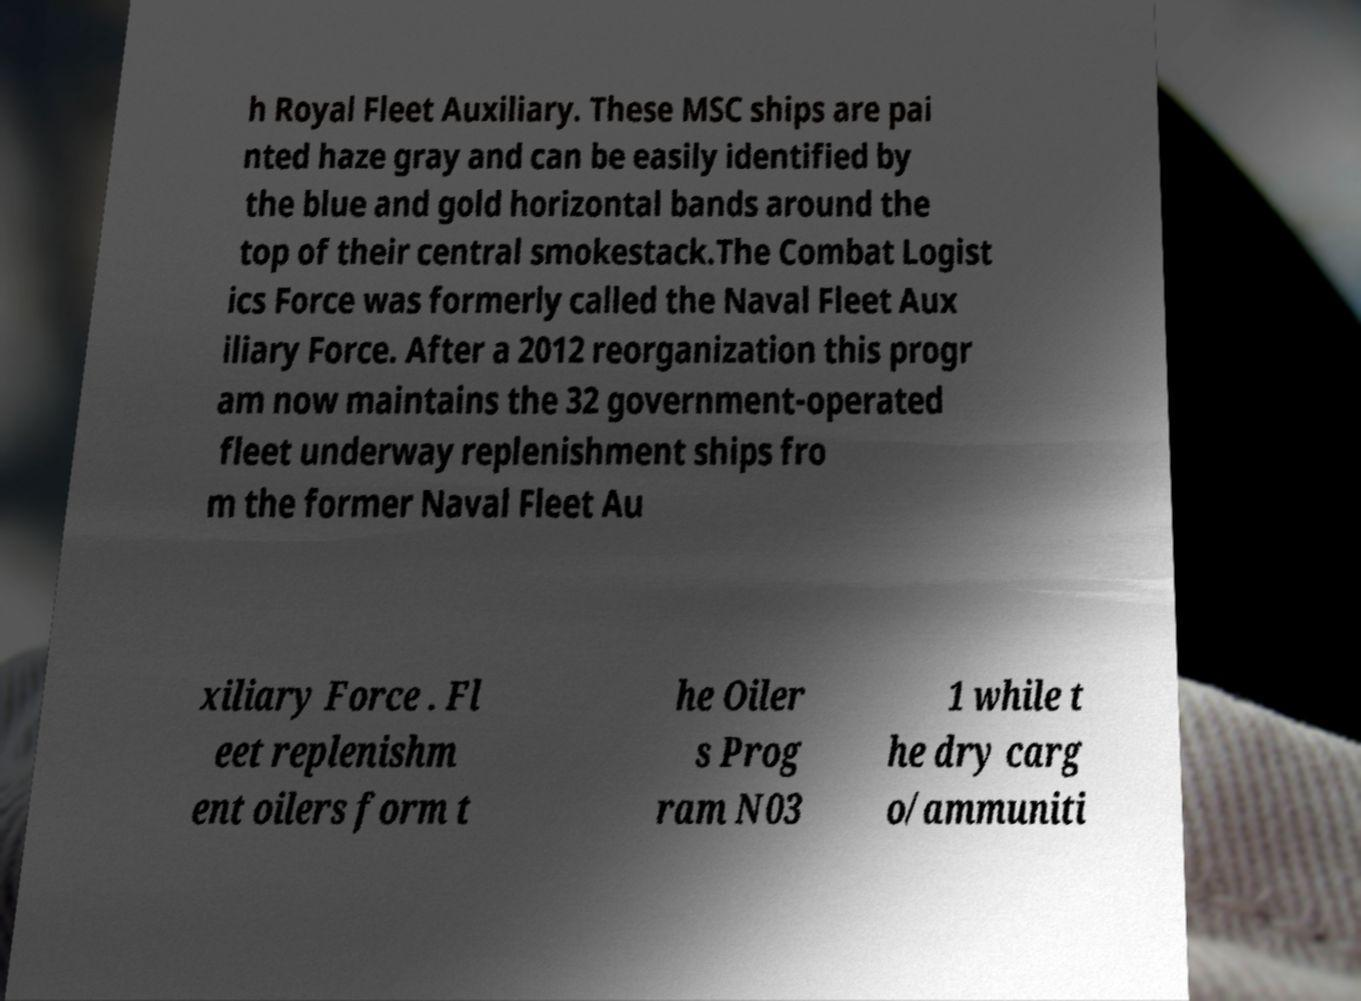What messages or text are displayed in this image? I need them in a readable, typed format. h Royal Fleet Auxiliary. These MSC ships are pai nted haze gray and can be easily identified by the blue and gold horizontal bands around the top of their central smokestack.The Combat Logist ics Force was formerly called the Naval Fleet Aux iliary Force. After a 2012 reorganization this progr am now maintains the 32 government-operated fleet underway replenishment ships fro m the former Naval Fleet Au xiliary Force . Fl eet replenishm ent oilers form t he Oiler s Prog ram N03 1 while t he dry carg o/ammuniti 